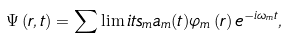<formula> <loc_0><loc_0><loc_500><loc_500>\Psi \left ( { r } , t \right ) = \sum \lim i t s _ { m } { a _ { m } ( t ) \varphi _ { m } \left ( { r } \right ) \, } e ^ { - i \omega _ { m } t } ,</formula> 